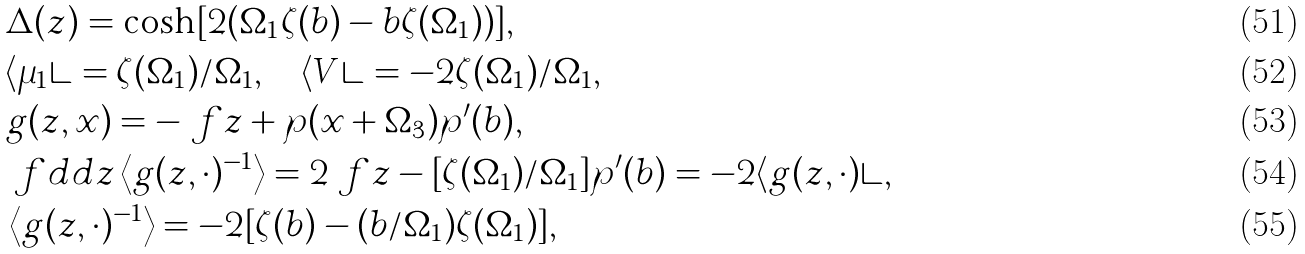<formula> <loc_0><loc_0><loc_500><loc_500>& \Delta ( z ) = \cosh [ 2 ( \Omega _ { 1 } \zeta ( b ) - b \zeta ( \Omega _ { 1 } ) ) ] , \\ & \langle \mu _ { 1 } \rangle = \zeta ( \Omega _ { 1 } ) / \Omega _ { 1 } , \quad \langle V \rangle = - 2 \zeta ( \Omega _ { 1 } ) / \Omega _ { 1 } , \\ & g ( z , x ) = - \ f { z + \wp ( x + \Omega _ { 3 } ) } { \wp ^ { \prime } ( b ) } , \\ & \ f { d } { d z } \left \langle g ( z , \cdot ) ^ { - 1 } \right \rangle = 2 \ f { z - [ \zeta ( \Omega _ { 1 } ) / \Omega _ { 1 } ] } { \wp ^ { \prime } ( b ) } = - 2 \langle g ( z , \cdot ) \rangle , \\ & \left \langle g ( z , \cdot ) ^ { - 1 } \right \rangle = - 2 [ \zeta ( b ) - ( b / \Omega _ { 1 } ) \zeta ( \Omega _ { 1 } ) ] ,</formula> 